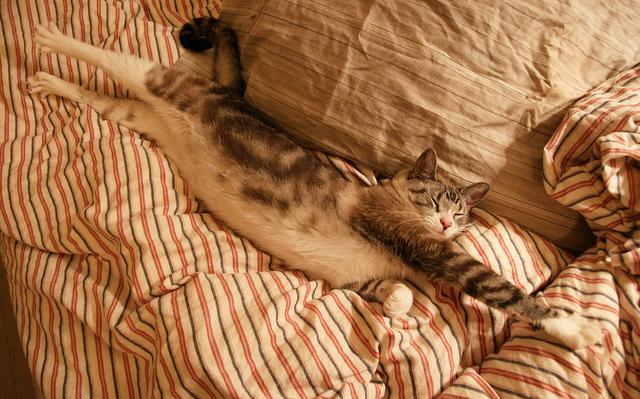What animal has this pattern?
Quick response, please. Cat. What is the cat laying on?
Write a very short answer. Bed. What position is the cat in?
Be succinct. Stretching. What do the cat and the comforter have in common?
Quick response, please. Striped. 